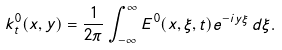<formula> <loc_0><loc_0><loc_500><loc_500>k _ { t } ^ { 0 } ( x , y ) = \frac { 1 } { 2 \pi } \int _ { - \infty } ^ { \infty } E ^ { 0 } ( x , \xi , t ) e ^ { - i y \xi } \, d \xi .</formula> 